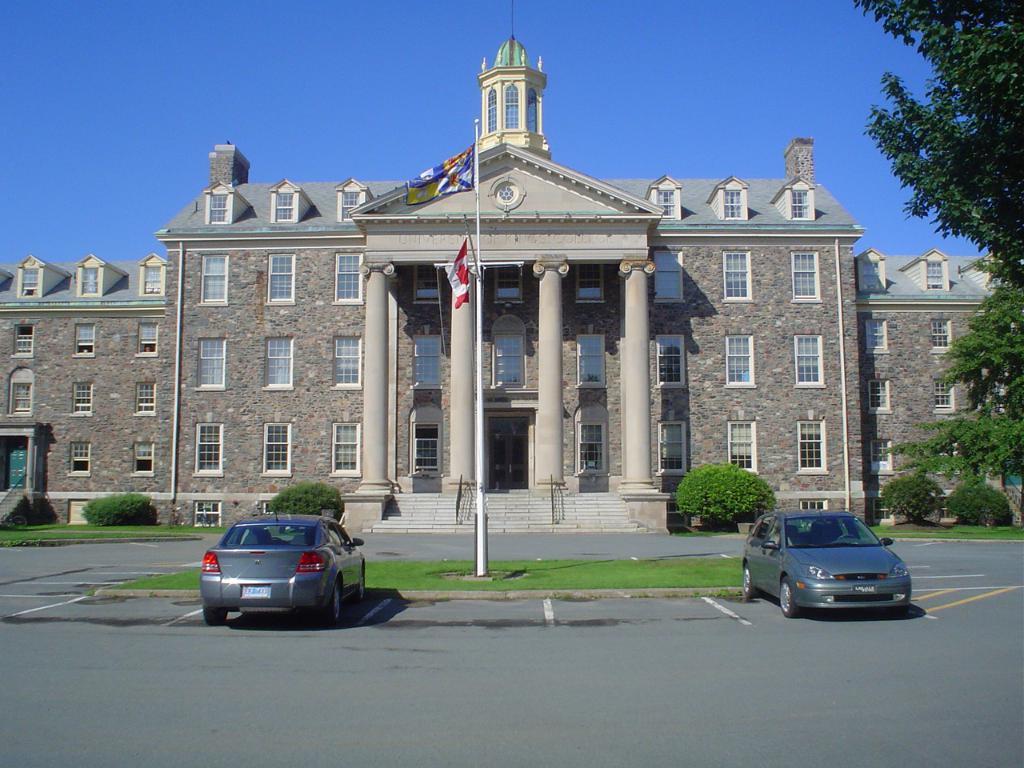In one or two sentences, can you explain what this image depicts? In this image I see a building over here and I see 2 flags and I see the road over here and I can also see the grass, bushes, 2 cars and the trees. In the background I see the blue sky. 